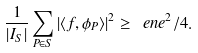Convert formula to latex. <formula><loc_0><loc_0><loc_500><loc_500>\frac { 1 } { | I _ { S } | } \sum _ { P \in S } | \langle f , \phi _ { P } \rangle | ^ { 2 } \geq \ e n e ^ { 2 } / 4 .</formula> 